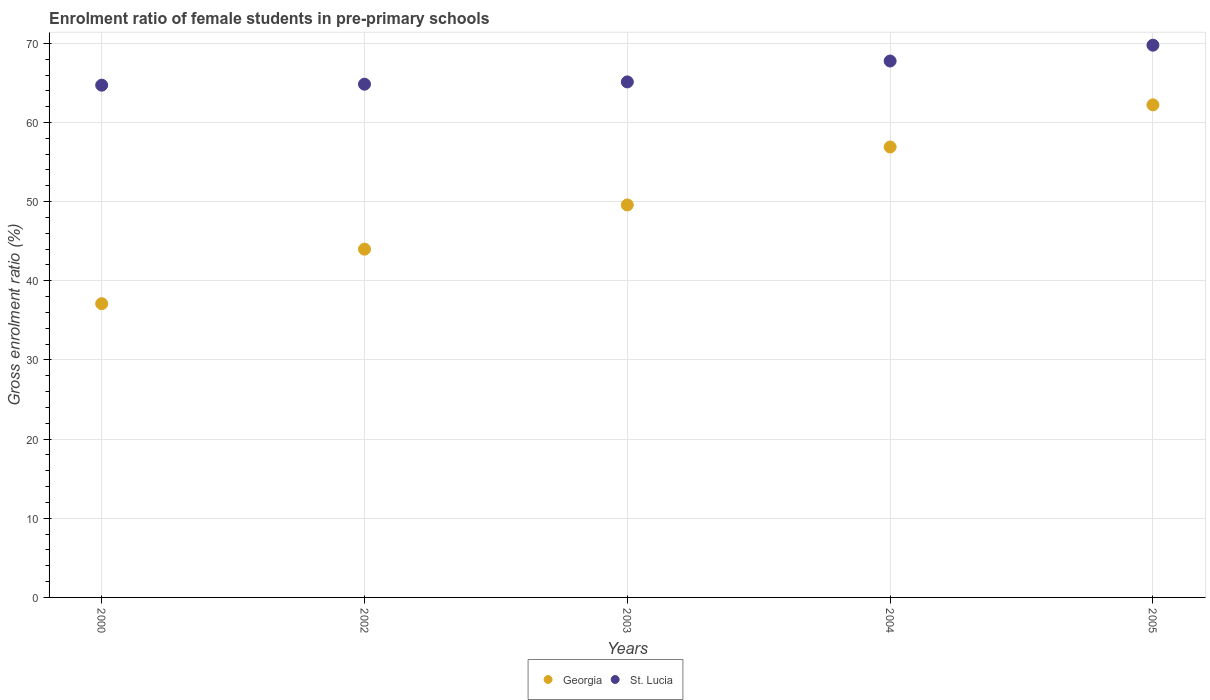What is the enrolment ratio of female students in pre-primary schools in St. Lucia in 2000?
Give a very brief answer. 64.72. Across all years, what is the maximum enrolment ratio of female students in pre-primary schools in Georgia?
Make the answer very short. 62.23. Across all years, what is the minimum enrolment ratio of female students in pre-primary schools in St. Lucia?
Your answer should be very brief. 64.72. In which year was the enrolment ratio of female students in pre-primary schools in Georgia maximum?
Make the answer very short. 2005. In which year was the enrolment ratio of female students in pre-primary schools in St. Lucia minimum?
Offer a very short reply. 2000. What is the total enrolment ratio of female students in pre-primary schools in St. Lucia in the graph?
Your answer should be compact. 332.22. What is the difference between the enrolment ratio of female students in pre-primary schools in St. Lucia in 2000 and that in 2005?
Provide a short and direct response. -5.05. What is the difference between the enrolment ratio of female students in pre-primary schools in Georgia in 2003 and the enrolment ratio of female students in pre-primary schools in St. Lucia in 2005?
Your answer should be compact. -20.19. What is the average enrolment ratio of female students in pre-primary schools in Georgia per year?
Provide a succinct answer. 49.97. In the year 2004, what is the difference between the enrolment ratio of female students in pre-primary schools in St. Lucia and enrolment ratio of female students in pre-primary schools in Georgia?
Make the answer very short. 10.86. In how many years, is the enrolment ratio of female students in pre-primary schools in Georgia greater than 26 %?
Offer a terse response. 5. What is the ratio of the enrolment ratio of female students in pre-primary schools in St. Lucia in 2002 to that in 2004?
Ensure brevity in your answer.  0.96. Is the enrolment ratio of female students in pre-primary schools in St. Lucia in 2003 less than that in 2005?
Offer a very short reply. Yes. Is the difference between the enrolment ratio of female students in pre-primary schools in St. Lucia in 2000 and 2002 greater than the difference between the enrolment ratio of female students in pre-primary schools in Georgia in 2000 and 2002?
Your answer should be compact. Yes. What is the difference between the highest and the second highest enrolment ratio of female students in pre-primary schools in St. Lucia?
Ensure brevity in your answer.  2. What is the difference between the highest and the lowest enrolment ratio of female students in pre-primary schools in St. Lucia?
Ensure brevity in your answer.  5.05. In how many years, is the enrolment ratio of female students in pre-primary schools in Georgia greater than the average enrolment ratio of female students in pre-primary schools in Georgia taken over all years?
Your answer should be very brief. 2. Is the sum of the enrolment ratio of female students in pre-primary schools in St. Lucia in 2000 and 2004 greater than the maximum enrolment ratio of female students in pre-primary schools in Georgia across all years?
Ensure brevity in your answer.  Yes. Does the enrolment ratio of female students in pre-primary schools in Georgia monotonically increase over the years?
Your answer should be compact. Yes. How many dotlines are there?
Offer a terse response. 2. Does the graph contain any zero values?
Make the answer very short. No. Does the graph contain grids?
Keep it short and to the point. Yes. Where does the legend appear in the graph?
Provide a short and direct response. Bottom center. How many legend labels are there?
Offer a very short reply. 2. How are the legend labels stacked?
Your response must be concise. Horizontal. What is the title of the graph?
Your answer should be very brief. Enrolment ratio of female students in pre-primary schools. What is the Gross enrolment ratio (%) in Georgia in 2000?
Provide a succinct answer. 37.11. What is the Gross enrolment ratio (%) of St. Lucia in 2000?
Ensure brevity in your answer.  64.72. What is the Gross enrolment ratio (%) in Georgia in 2002?
Ensure brevity in your answer.  44. What is the Gross enrolment ratio (%) of St. Lucia in 2002?
Provide a short and direct response. 64.84. What is the Gross enrolment ratio (%) in Georgia in 2003?
Offer a terse response. 49.58. What is the Gross enrolment ratio (%) in St. Lucia in 2003?
Make the answer very short. 65.13. What is the Gross enrolment ratio (%) of Georgia in 2004?
Give a very brief answer. 56.91. What is the Gross enrolment ratio (%) in St. Lucia in 2004?
Your answer should be compact. 67.77. What is the Gross enrolment ratio (%) of Georgia in 2005?
Your answer should be compact. 62.23. What is the Gross enrolment ratio (%) of St. Lucia in 2005?
Your answer should be compact. 69.77. Across all years, what is the maximum Gross enrolment ratio (%) of Georgia?
Your answer should be compact. 62.23. Across all years, what is the maximum Gross enrolment ratio (%) in St. Lucia?
Keep it short and to the point. 69.77. Across all years, what is the minimum Gross enrolment ratio (%) of Georgia?
Offer a very short reply. 37.11. Across all years, what is the minimum Gross enrolment ratio (%) of St. Lucia?
Your answer should be very brief. 64.72. What is the total Gross enrolment ratio (%) of Georgia in the graph?
Make the answer very short. 249.83. What is the total Gross enrolment ratio (%) in St. Lucia in the graph?
Your answer should be compact. 332.22. What is the difference between the Gross enrolment ratio (%) of Georgia in 2000 and that in 2002?
Make the answer very short. -6.89. What is the difference between the Gross enrolment ratio (%) of St. Lucia in 2000 and that in 2002?
Your answer should be compact. -0.12. What is the difference between the Gross enrolment ratio (%) of Georgia in 2000 and that in 2003?
Ensure brevity in your answer.  -12.47. What is the difference between the Gross enrolment ratio (%) in St. Lucia in 2000 and that in 2003?
Ensure brevity in your answer.  -0.41. What is the difference between the Gross enrolment ratio (%) in Georgia in 2000 and that in 2004?
Ensure brevity in your answer.  -19.8. What is the difference between the Gross enrolment ratio (%) in St. Lucia in 2000 and that in 2004?
Your answer should be compact. -3.05. What is the difference between the Gross enrolment ratio (%) in Georgia in 2000 and that in 2005?
Give a very brief answer. -25.12. What is the difference between the Gross enrolment ratio (%) in St. Lucia in 2000 and that in 2005?
Provide a succinct answer. -5.05. What is the difference between the Gross enrolment ratio (%) of Georgia in 2002 and that in 2003?
Keep it short and to the point. -5.59. What is the difference between the Gross enrolment ratio (%) of St. Lucia in 2002 and that in 2003?
Provide a succinct answer. -0.29. What is the difference between the Gross enrolment ratio (%) in Georgia in 2002 and that in 2004?
Offer a terse response. -12.91. What is the difference between the Gross enrolment ratio (%) of St. Lucia in 2002 and that in 2004?
Ensure brevity in your answer.  -2.93. What is the difference between the Gross enrolment ratio (%) in Georgia in 2002 and that in 2005?
Ensure brevity in your answer.  -18.24. What is the difference between the Gross enrolment ratio (%) of St. Lucia in 2002 and that in 2005?
Offer a very short reply. -4.93. What is the difference between the Gross enrolment ratio (%) of Georgia in 2003 and that in 2004?
Offer a terse response. -7.32. What is the difference between the Gross enrolment ratio (%) in St. Lucia in 2003 and that in 2004?
Offer a very short reply. -2.64. What is the difference between the Gross enrolment ratio (%) of Georgia in 2003 and that in 2005?
Your answer should be compact. -12.65. What is the difference between the Gross enrolment ratio (%) of St. Lucia in 2003 and that in 2005?
Offer a terse response. -4.64. What is the difference between the Gross enrolment ratio (%) of Georgia in 2004 and that in 2005?
Offer a very short reply. -5.33. What is the difference between the Gross enrolment ratio (%) in St. Lucia in 2004 and that in 2005?
Keep it short and to the point. -2. What is the difference between the Gross enrolment ratio (%) in Georgia in 2000 and the Gross enrolment ratio (%) in St. Lucia in 2002?
Offer a very short reply. -27.73. What is the difference between the Gross enrolment ratio (%) in Georgia in 2000 and the Gross enrolment ratio (%) in St. Lucia in 2003?
Your response must be concise. -28.02. What is the difference between the Gross enrolment ratio (%) of Georgia in 2000 and the Gross enrolment ratio (%) of St. Lucia in 2004?
Give a very brief answer. -30.66. What is the difference between the Gross enrolment ratio (%) of Georgia in 2000 and the Gross enrolment ratio (%) of St. Lucia in 2005?
Make the answer very short. -32.66. What is the difference between the Gross enrolment ratio (%) in Georgia in 2002 and the Gross enrolment ratio (%) in St. Lucia in 2003?
Your answer should be compact. -21.13. What is the difference between the Gross enrolment ratio (%) of Georgia in 2002 and the Gross enrolment ratio (%) of St. Lucia in 2004?
Your answer should be compact. -23.77. What is the difference between the Gross enrolment ratio (%) of Georgia in 2002 and the Gross enrolment ratio (%) of St. Lucia in 2005?
Offer a very short reply. -25.77. What is the difference between the Gross enrolment ratio (%) of Georgia in 2003 and the Gross enrolment ratio (%) of St. Lucia in 2004?
Give a very brief answer. -18.18. What is the difference between the Gross enrolment ratio (%) of Georgia in 2003 and the Gross enrolment ratio (%) of St. Lucia in 2005?
Provide a short and direct response. -20.19. What is the difference between the Gross enrolment ratio (%) of Georgia in 2004 and the Gross enrolment ratio (%) of St. Lucia in 2005?
Make the answer very short. -12.86. What is the average Gross enrolment ratio (%) of Georgia per year?
Make the answer very short. 49.97. What is the average Gross enrolment ratio (%) of St. Lucia per year?
Offer a terse response. 66.44. In the year 2000, what is the difference between the Gross enrolment ratio (%) of Georgia and Gross enrolment ratio (%) of St. Lucia?
Keep it short and to the point. -27.61. In the year 2002, what is the difference between the Gross enrolment ratio (%) in Georgia and Gross enrolment ratio (%) in St. Lucia?
Give a very brief answer. -20.84. In the year 2003, what is the difference between the Gross enrolment ratio (%) in Georgia and Gross enrolment ratio (%) in St. Lucia?
Ensure brevity in your answer.  -15.55. In the year 2004, what is the difference between the Gross enrolment ratio (%) of Georgia and Gross enrolment ratio (%) of St. Lucia?
Offer a very short reply. -10.86. In the year 2005, what is the difference between the Gross enrolment ratio (%) of Georgia and Gross enrolment ratio (%) of St. Lucia?
Your response must be concise. -7.54. What is the ratio of the Gross enrolment ratio (%) in Georgia in 2000 to that in 2002?
Offer a very short reply. 0.84. What is the ratio of the Gross enrolment ratio (%) of Georgia in 2000 to that in 2003?
Give a very brief answer. 0.75. What is the ratio of the Gross enrolment ratio (%) in Georgia in 2000 to that in 2004?
Provide a succinct answer. 0.65. What is the ratio of the Gross enrolment ratio (%) of St. Lucia in 2000 to that in 2004?
Give a very brief answer. 0.95. What is the ratio of the Gross enrolment ratio (%) in Georgia in 2000 to that in 2005?
Your answer should be compact. 0.6. What is the ratio of the Gross enrolment ratio (%) in St. Lucia in 2000 to that in 2005?
Your answer should be compact. 0.93. What is the ratio of the Gross enrolment ratio (%) in Georgia in 2002 to that in 2003?
Make the answer very short. 0.89. What is the ratio of the Gross enrolment ratio (%) in St. Lucia in 2002 to that in 2003?
Your response must be concise. 1. What is the ratio of the Gross enrolment ratio (%) in Georgia in 2002 to that in 2004?
Keep it short and to the point. 0.77. What is the ratio of the Gross enrolment ratio (%) in St. Lucia in 2002 to that in 2004?
Keep it short and to the point. 0.96. What is the ratio of the Gross enrolment ratio (%) in Georgia in 2002 to that in 2005?
Give a very brief answer. 0.71. What is the ratio of the Gross enrolment ratio (%) in St. Lucia in 2002 to that in 2005?
Offer a terse response. 0.93. What is the ratio of the Gross enrolment ratio (%) of Georgia in 2003 to that in 2004?
Offer a very short reply. 0.87. What is the ratio of the Gross enrolment ratio (%) in St. Lucia in 2003 to that in 2004?
Offer a terse response. 0.96. What is the ratio of the Gross enrolment ratio (%) in Georgia in 2003 to that in 2005?
Ensure brevity in your answer.  0.8. What is the ratio of the Gross enrolment ratio (%) of St. Lucia in 2003 to that in 2005?
Offer a very short reply. 0.93. What is the ratio of the Gross enrolment ratio (%) of Georgia in 2004 to that in 2005?
Keep it short and to the point. 0.91. What is the ratio of the Gross enrolment ratio (%) of St. Lucia in 2004 to that in 2005?
Ensure brevity in your answer.  0.97. What is the difference between the highest and the second highest Gross enrolment ratio (%) in Georgia?
Give a very brief answer. 5.33. What is the difference between the highest and the second highest Gross enrolment ratio (%) of St. Lucia?
Provide a short and direct response. 2. What is the difference between the highest and the lowest Gross enrolment ratio (%) in Georgia?
Keep it short and to the point. 25.12. What is the difference between the highest and the lowest Gross enrolment ratio (%) of St. Lucia?
Provide a short and direct response. 5.05. 